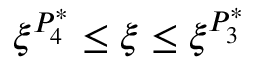<formula> <loc_0><loc_0><loc_500><loc_500>\xi ^ { P _ { 4 } ^ { * } } \leq \xi \leq \xi ^ { P _ { 3 } ^ { * } }</formula> 